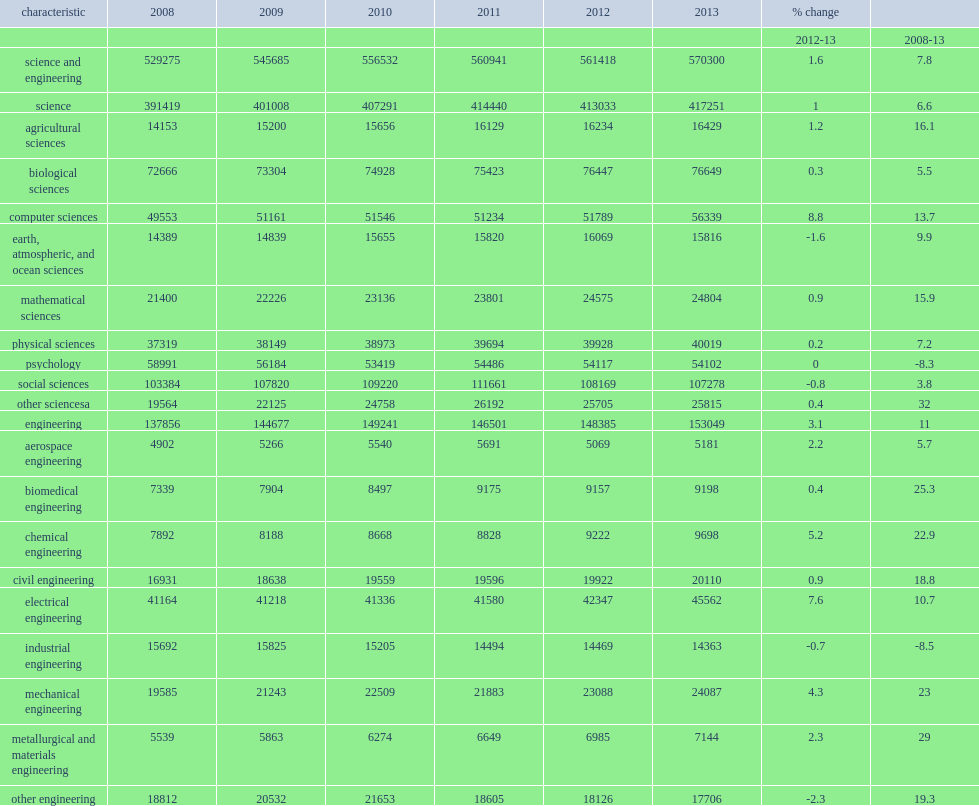In 2013, how many s&e graduate students were enrolled in science and engineering fields? 570300.0. In 2013, how many percent of the 570,300 s&e graduate students were enrolled in science fields? 0.731634. In 2013, how many percent of the 570,300 s&e graduate students were enrolled in engineering fields? 0.268366. Graduate enrollment in the various science fields remained fairly flat from 2012 to 2013, except for computer sciences, how many percent did it jumped by? 8.8. Graduate enrollment in the various science fields remained fairly flat from 2012 to 2013, except for computer sciences, how many percent did it contributed to growth of overall graduate enrollment in science from 2012? 1.0. 